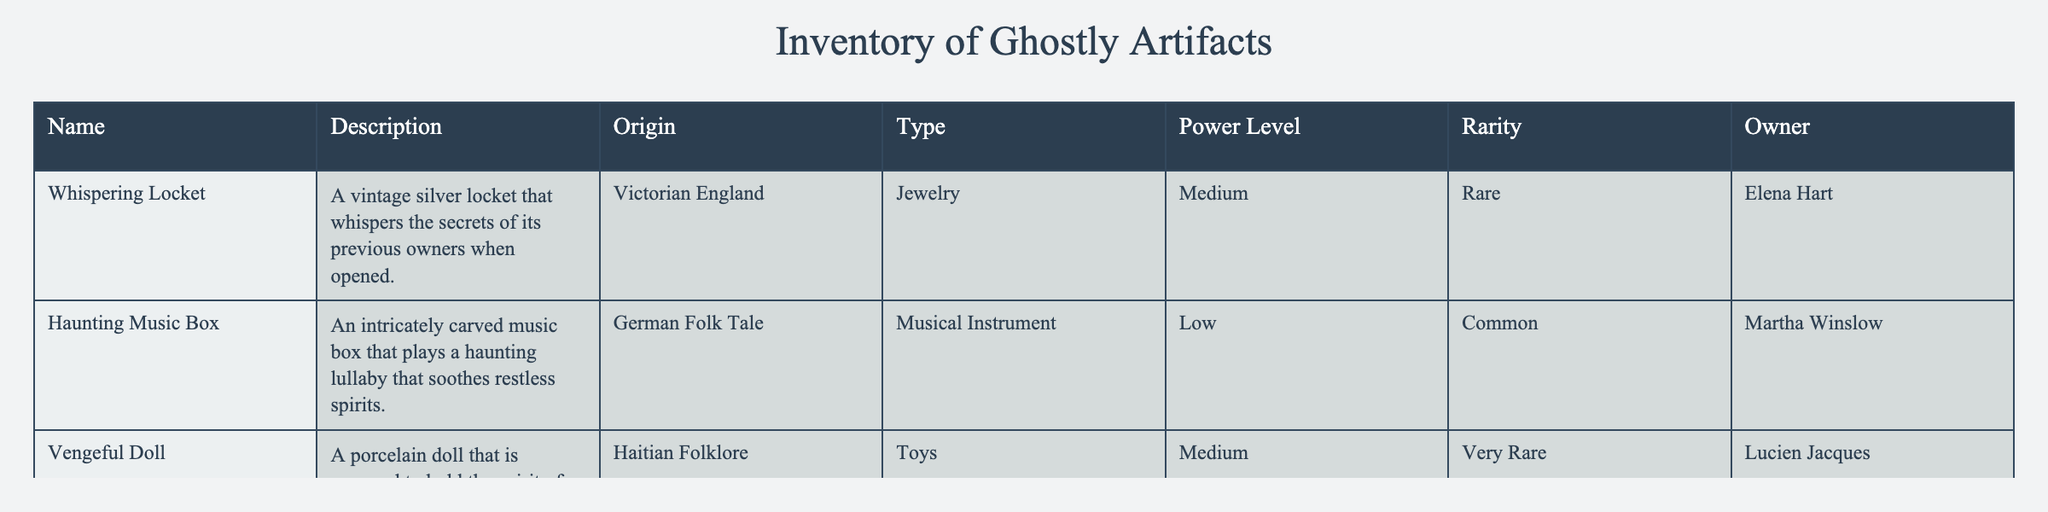What is the highest power level among the artifacts? The artifacts listed in the table have varying power levels. By checking the "Power Level" column, the highest mentioned power level is "Medium," which appears for both the Whispering Locket and the Vengeful Doll.
Answer: Medium Which artifact is owned by Lucien Jacques? Referring to the "Owner" column, it is clear that the artifact owned by Lucien Jacques is the "Vengeful Doll."
Answer: Vengeful Doll Is there any artifact with a "Low" power level? Inspecting the "Power Level" column, there is indeed an artifact with a "Low" power level, specifically the "Haunting Music Box."
Answer: Yes How many artifacts are classified as "Rare"? The "Rarity" column indicates that there are two artifacts classified as "Rare": the "Whispering Locket" and the "Vengeful Doll." Thus, the count is 2.
Answer: 2 Which type of artifact does Elena Hart own? Looking at the table, the "Owner" column shows that Elena Hart possesses the "Whispering Locket," which falls under the "Jewelry" category as per the "Type" column.
Answer: Jewelry What is the average power level of the artifacts in the table? The provided power levels are Low (1), Medium (2), and Very Rare (3). Mapping the levels to their corresponding numbers, we have: Haunting Music Box = 1, Whispering Locket = 2, Vengeful Doll = 2 (as it is also considered Medium), totaling 5, then dividing by 3 gives an average of 1.67, which corresponds to Medium.
Answer: Medium Are there any musical instruments listed in the inventory? The inventory lists the "Haunting Music Box" as a musical instrument in the "Type" column, making it a definite presence in the inventory.
Answer: Yes What is the origin of the Vengeful Doll? According to the "Origin" column, the Vengeful Doll has its origins in Haitian Folklore.
Answer: Haitian Folklore 